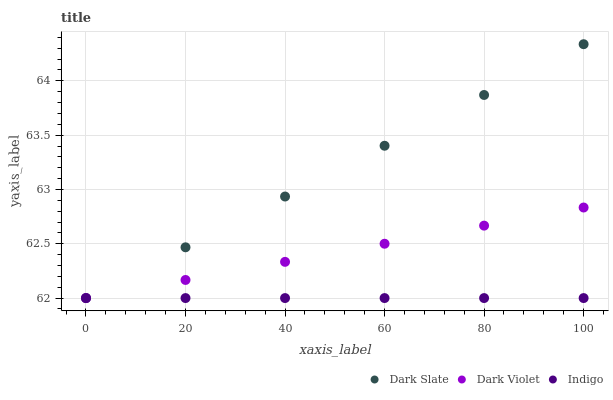Does Indigo have the minimum area under the curve?
Answer yes or no. Yes. Does Dark Slate have the maximum area under the curve?
Answer yes or no. Yes. Does Dark Violet have the minimum area under the curve?
Answer yes or no. No. Does Dark Violet have the maximum area under the curve?
Answer yes or no. No. Is Indigo the smoothest?
Answer yes or no. Yes. Is Dark Violet the roughest?
Answer yes or no. Yes. Is Dark Violet the smoothest?
Answer yes or no. No. Is Indigo the roughest?
Answer yes or no. No. Does Dark Slate have the lowest value?
Answer yes or no. Yes. Does Dark Slate have the highest value?
Answer yes or no. Yes. Does Dark Violet have the highest value?
Answer yes or no. No. Does Dark Violet intersect Dark Slate?
Answer yes or no. Yes. Is Dark Violet less than Dark Slate?
Answer yes or no. No. Is Dark Violet greater than Dark Slate?
Answer yes or no. No. 